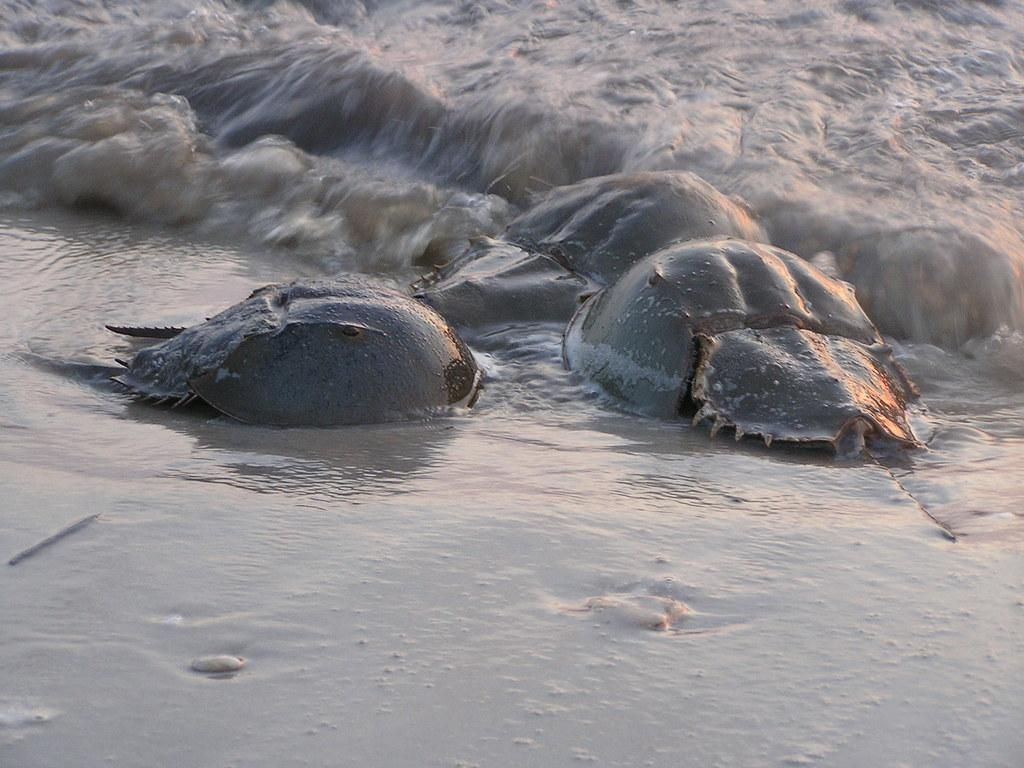What type of animals can be seen in the image? There are water animals in the image. Where are the water animals located? The water animals are on the sea shore. What can be seen in the background of the image? There is water visible in the background of the image. What type of hair can be seen on the water animals in the image? There is no hair visible on the water animals in the image, as they are aquatic creatures. 